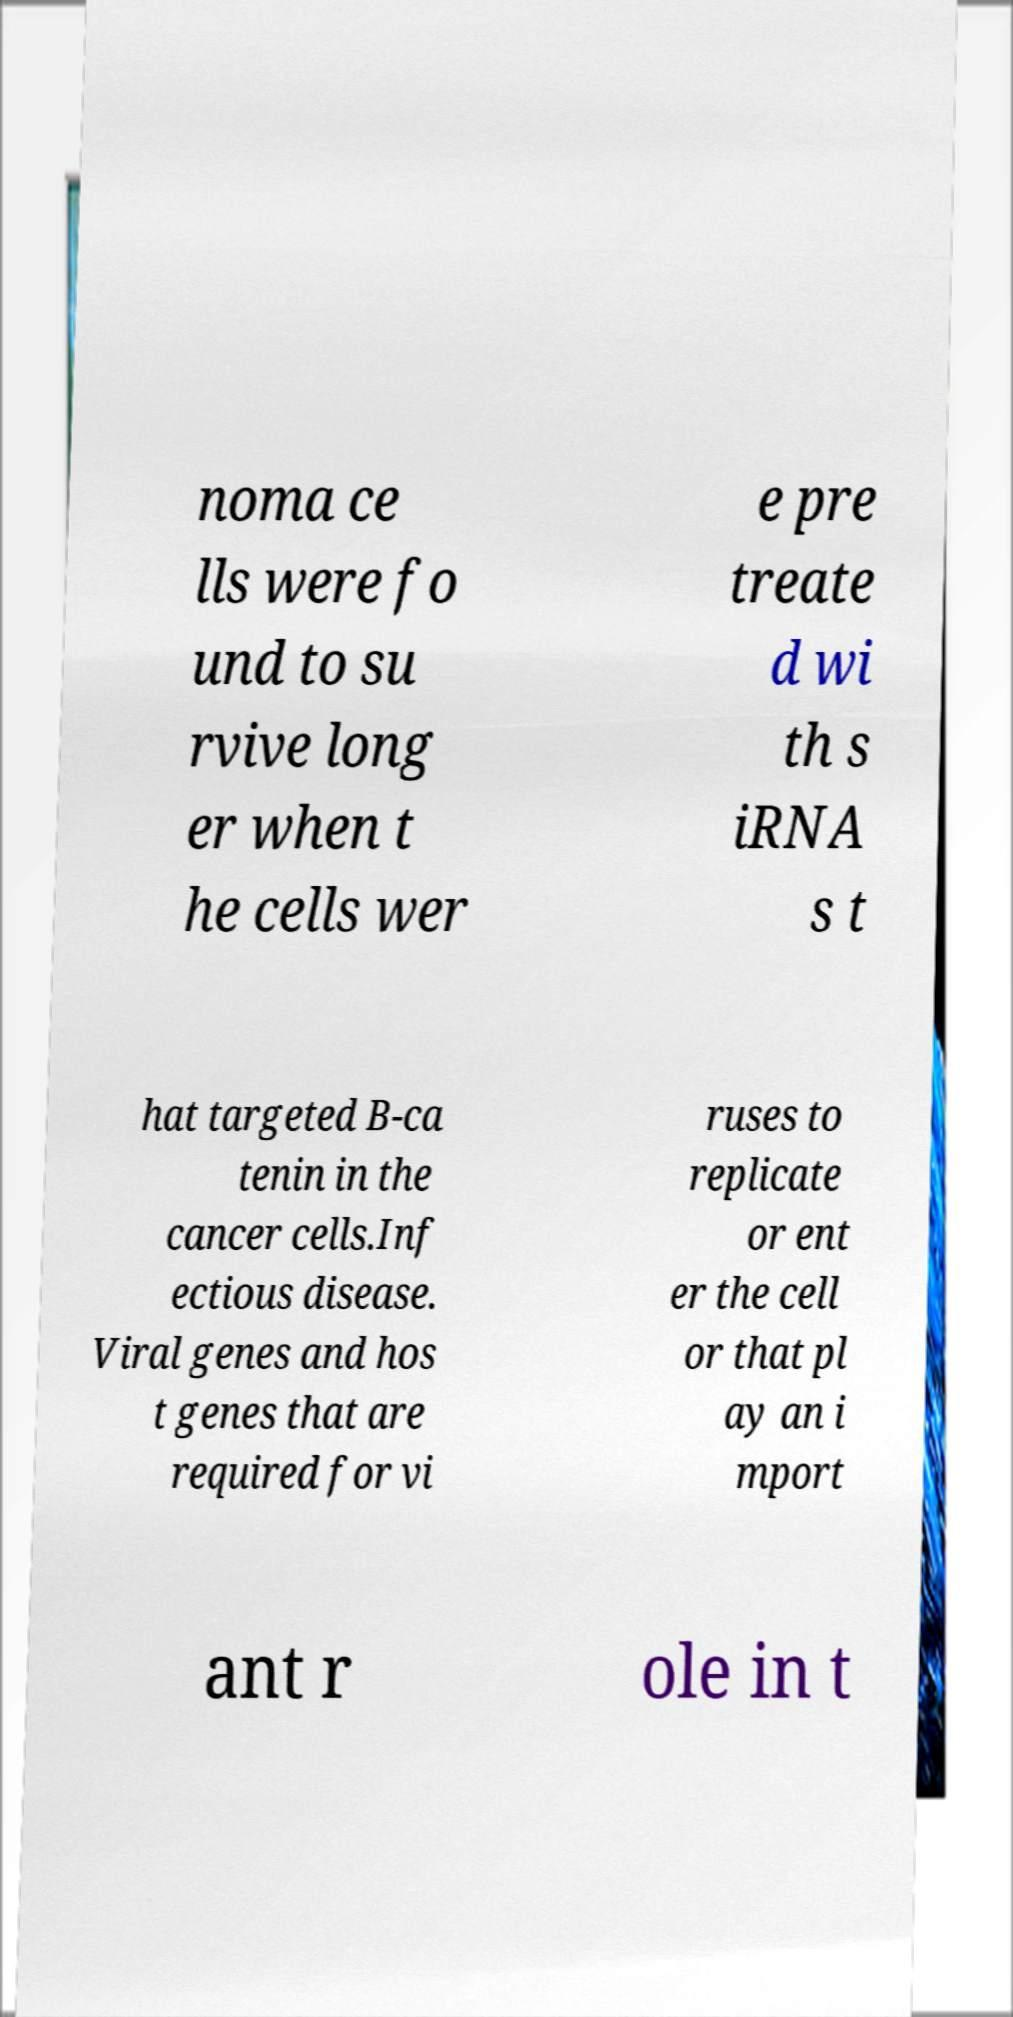For documentation purposes, I need the text within this image transcribed. Could you provide that? noma ce lls were fo und to su rvive long er when t he cells wer e pre treate d wi th s iRNA s t hat targeted B-ca tenin in the cancer cells.Inf ectious disease. Viral genes and hos t genes that are required for vi ruses to replicate or ent er the cell or that pl ay an i mport ant r ole in t 